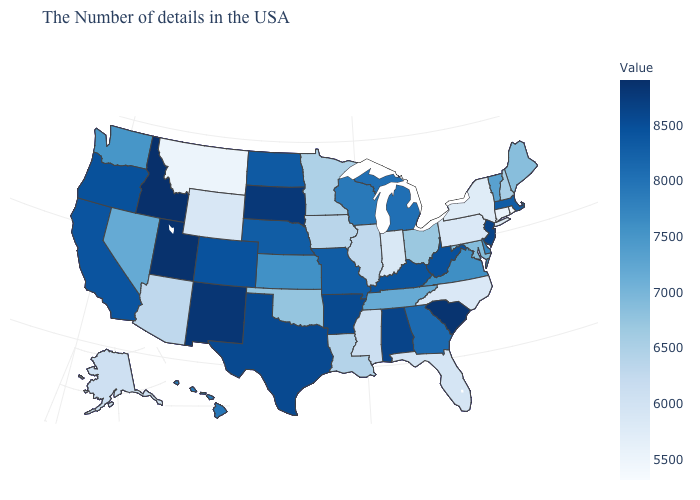Does the map have missing data?
Answer briefly. No. Which states have the lowest value in the USA?
Answer briefly. Rhode Island. Among the states that border Kansas , which have the highest value?
Concise answer only. Colorado. 